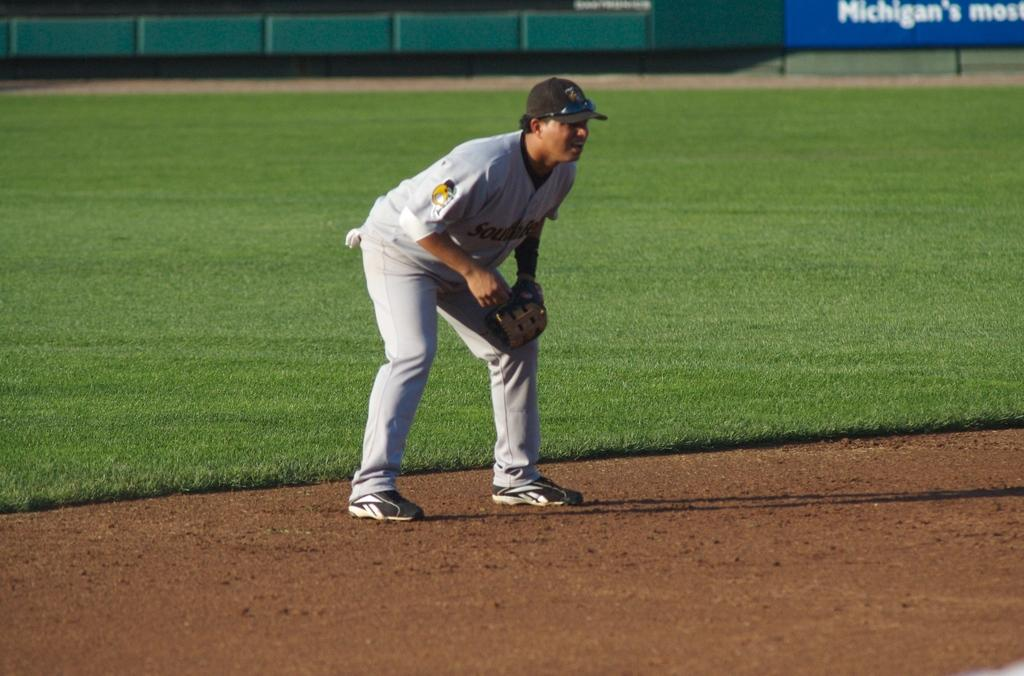<image>
Write a terse but informative summary of the picture. A blue sign with Michigan written on it is shown on the outfield wall of a baseball field while a fielder readies for the next play. 